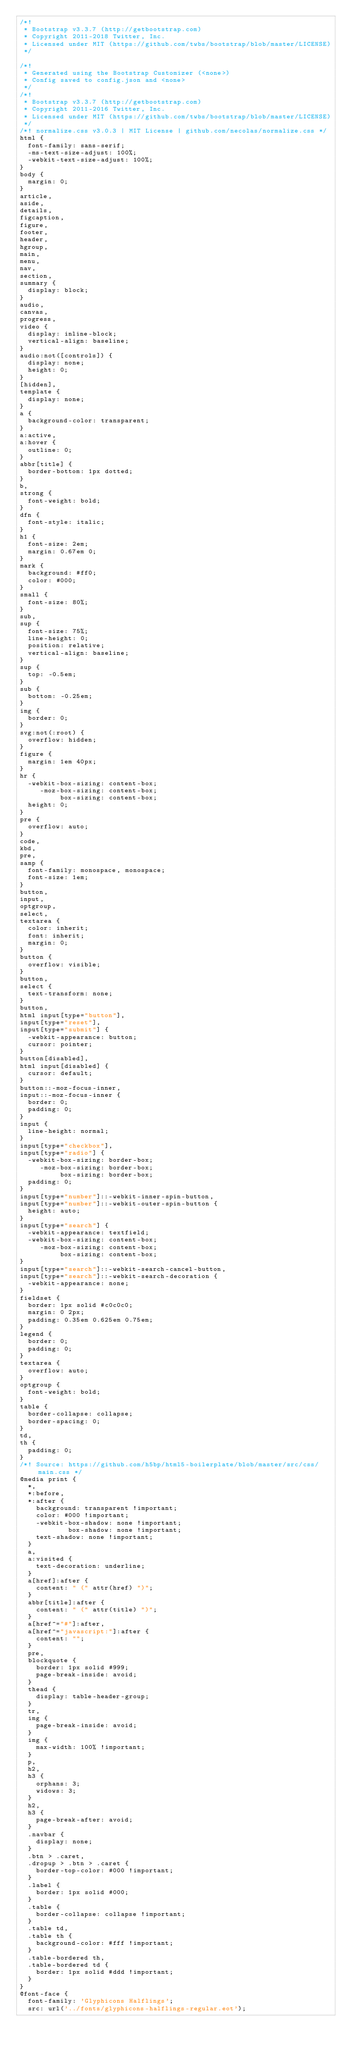Convert code to text. <code><loc_0><loc_0><loc_500><loc_500><_CSS_>/*!
 * Bootstrap v3.3.7 (http://getbootstrap.com)
 * Copyright 2011-2018 Twitter, Inc.
 * Licensed under MIT (https://github.com/twbs/bootstrap/blob/master/LICENSE)
 */

/*!
 * Generated using the Bootstrap Customizer (<none>)
 * Config saved to config.json and <none>
 */
/*!
 * Bootstrap v3.3.7 (http://getbootstrap.com)
 * Copyright 2011-2016 Twitter, Inc.
 * Licensed under MIT (https://github.com/twbs/bootstrap/blob/master/LICENSE)
 */
/*! normalize.css v3.0.3 | MIT License | github.com/necolas/normalize.css */
html {
  font-family: sans-serif;
  -ms-text-size-adjust: 100%;
  -webkit-text-size-adjust: 100%;
}
body {
  margin: 0;
}
article,
aside,
details,
figcaption,
figure,
footer,
header,
hgroup,
main,
menu,
nav,
section,
summary {
  display: block;
}
audio,
canvas,
progress,
video {
  display: inline-block;
  vertical-align: baseline;
}
audio:not([controls]) {
  display: none;
  height: 0;
}
[hidden],
template {
  display: none;
}
a {
  background-color: transparent;
}
a:active,
a:hover {
  outline: 0;
}
abbr[title] {
  border-bottom: 1px dotted;
}
b,
strong {
  font-weight: bold;
}
dfn {
  font-style: italic;
}
h1 {
  font-size: 2em;
  margin: 0.67em 0;
}
mark {
  background: #ff0;
  color: #000;
}
small {
  font-size: 80%;
}
sub,
sup {
  font-size: 75%;
  line-height: 0;
  position: relative;
  vertical-align: baseline;
}
sup {
  top: -0.5em;
}
sub {
  bottom: -0.25em;
}
img {
  border: 0;
}
svg:not(:root) {
  overflow: hidden;
}
figure {
  margin: 1em 40px;
}
hr {
  -webkit-box-sizing: content-box;
     -moz-box-sizing: content-box;
          box-sizing: content-box;
  height: 0;
}
pre {
  overflow: auto;
}
code,
kbd,
pre,
samp {
  font-family: monospace, monospace;
  font-size: 1em;
}
button,
input,
optgroup,
select,
textarea {
  color: inherit;
  font: inherit;
  margin: 0;
}
button {
  overflow: visible;
}
button,
select {
  text-transform: none;
}
button,
html input[type="button"],
input[type="reset"],
input[type="submit"] {
  -webkit-appearance: button;
  cursor: pointer;
}
button[disabled],
html input[disabled] {
  cursor: default;
}
button::-moz-focus-inner,
input::-moz-focus-inner {
  border: 0;
  padding: 0;
}
input {
  line-height: normal;
}
input[type="checkbox"],
input[type="radio"] {
  -webkit-box-sizing: border-box;
     -moz-box-sizing: border-box;
          box-sizing: border-box;
  padding: 0;
}
input[type="number"]::-webkit-inner-spin-button,
input[type="number"]::-webkit-outer-spin-button {
  height: auto;
}
input[type="search"] {
  -webkit-appearance: textfield;
  -webkit-box-sizing: content-box;
     -moz-box-sizing: content-box;
          box-sizing: content-box;
}
input[type="search"]::-webkit-search-cancel-button,
input[type="search"]::-webkit-search-decoration {
  -webkit-appearance: none;
}
fieldset {
  border: 1px solid #c0c0c0;
  margin: 0 2px;
  padding: 0.35em 0.625em 0.75em;
}
legend {
  border: 0;
  padding: 0;
}
textarea {
  overflow: auto;
}
optgroup {
  font-weight: bold;
}
table {
  border-collapse: collapse;
  border-spacing: 0;
}
td,
th {
  padding: 0;
}
/*! Source: https://github.com/h5bp/html5-boilerplate/blob/master/src/css/main.css */
@media print {
  *,
  *:before,
  *:after {
    background: transparent !important;
    color: #000 !important;
    -webkit-box-shadow: none !important;
            box-shadow: none !important;
    text-shadow: none !important;
  }
  a,
  a:visited {
    text-decoration: underline;
  }
  a[href]:after {
    content: " (" attr(href) ")";
  }
  abbr[title]:after {
    content: " (" attr(title) ")";
  }
  a[href^="#"]:after,
  a[href^="javascript:"]:after {
    content: "";
  }
  pre,
  blockquote {
    border: 1px solid #999;
    page-break-inside: avoid;
  }
  thead {
    display: table-header-group;
  }
  tr,
  img {
    page-break-inside: avoid;
  }
  img {
    max-width: 100% !important;
  }
  p,
  h2,
  h3 {
    orphans: 3;
    widows: 3;
  }
  h2,
  h3 {
    page-break-after: avoid;
  }
  .navbar {
    display: none;
  }
  .btn > .caret,
  .dropup > .btn > .caret {
    border-top-color: #000 !important;
  }
  .label {
    border: 1px solid #000;
  }
  .table {
    border-collapse: collapse !important;
  }
  .table td,
  .table th {
    background-color: #fff !important;
  }
  .table-bordered th,
  .table-bordered td {
    border: 1px solid #ddd !important;
  }
}
@font-face {
  font-family: 'Glyphicons Halflings';
  src: url('../fonts/glyphicons-halflings-regular.eot');</code> 